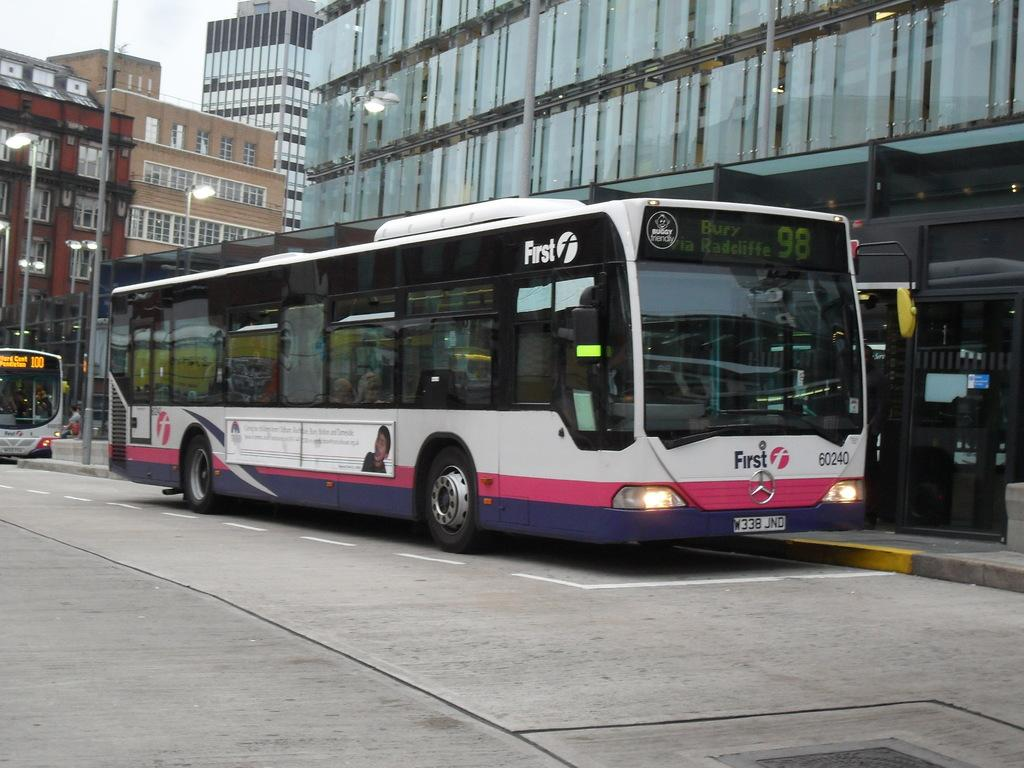<image>
Describe the image concisely. bus number 98 going to bury via radcliffe 